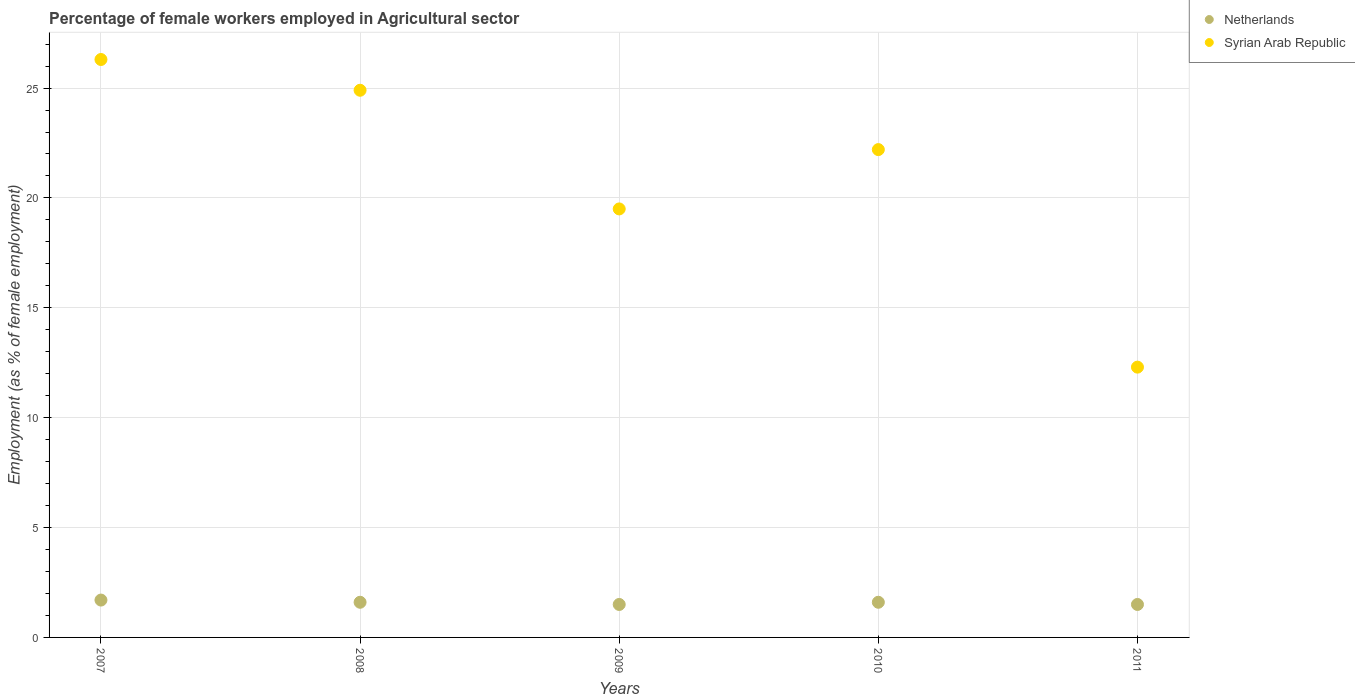How many different coloured dotlines are there?
Give a very brief answer. 2. What is the percentage of females employed in Agricultural sector in Netherlands in 2008?
Make the answer very short. 1.6. Across all years, what is the maximum percentage of females employed in Agricultural sector in Syrian Arab Republic?
Your response must be concise. 26.3. In which year was the percentage of females employed in Agricultural sector in Netherlands maximum?
Offer a very short reply. 2007. In which year was the percentage of females employed in Agricultural sector in Netherlands minimum?
Offer a very short reply. 2009. What is the total percentage of females employed in Agricultural sector in Netherlands in the graph?
Your response must be concise. 7.9. What is the difference between the percentage of females employed in Agricultural sector in Syrian Arab Republic in 2009 and that in 2010?
Your response must be concise. -2.7. What is the difference between the percentage of females employed in Agricultural sector in Syrian Arab Republic in 2007 and the percentage of females employed in Agricultural sector in Netherlands in 2010?
Your answer should be very brief. 24.7. What is the average percentage of females employed in Agricultural sector in Syrian Arab Republic per year?
Your response must be concise. 21.04. In the year 2007, what is the difference between the percentage of females employed in Agricultural sector in Syrian Arab Republic and percentage of females employed in Agricultural sector in Netherlands?
Provide a succinct answer. 24.6. In how many years, is the percentage of females employed in Agricultural sector in Netherlands greater than 10 %?
Ensure brevity in your answer.  0. What is the ratio of the percentage of females employed in Agricultural sector in Netherlands in 2010 to that in 2011?
Offer a very short reply. 1.07. Is the difference between the percentage of females employed in Agricultural sector in Syrian Arab Republic in 2008 and 2009 greater than the difference between the percentage of females employed in Agricultural sector in Netherlands in 2008 and 2009?
Give a very brief answer. Yes. What is the difference between the highest and the second highest percentage of females employed in Agricultural sector in Netherlands?
Ensure brevity in your answer.  0.1. What is the difference between the highest and the lowest percentage of females employed in Agricultural sector in Syrian Arab Republic?
Your answer should be very brief. 14. Is the sum of the percentage of females employed in Agricultural sector in Netherlands in 2008 and 2009 greater than the maximum percentage of females employed in Agricultural sector in Syrian Arab Republic across all years?
Give a very brief answer. No. How many dotlines are there?
Make the answer very short. 2. What is the difference between two consecutive major ticks on the Y-axis?
Offer a terse response. 5. Are the values on the major ticks of Y-axis written in scientific E-notation?
Give a very brief answer. No. Does the graph contain grids?
Give a very brief answer. Yes. How many legend labels are there?
Your response must be concise. 2. How are the legend labels stacked?
Ensure brevity in your answer.  Vertical. What is the title of the graph?
Provide a succinct answer. Percentage of female workers employed in Agricultural sector. What is the label or title of the Y-axis?
Offer a terse response. Employment (as % of female employment). What is the Employment (as % of female employment) of Netherlands in 2007?
Your answer should be very brief. 1.7. What is the Employment (as % of female employment) of Syrian Arab Republic in 2007?
Keep it short and to the point. 26.3. What is the Employment (as % of female employment) of Netherlands in 2008?
Your answer should be very brief. 1.6. What is the Employment (as % of female employment) in Syrian Arab Republic in 2008?
Give a very brief answer. 24.9. What is the Employment (as % of female employment) of Netherlands in 2009?
Keep it short and to the point. 1.5. What is the Employment (as % of female employment) of Syrian Arab Republic in 2009?
Your answer should be very brief. 19.5. What is the Employment (as % of female employment) of Netherlands in 2010?
Provide a succinct answer. 1.6. What is the Employment (as % of female employment) of Syrian Arab Republic in 2010?
Ensure brevity in your answer.  22.2. What is the Employment (as % of female employment) in Netherlands in 2011?
Your response must be concise. 1.5. What is the Employment (as % of female employment) of Syrian Arab Republic in 2011?
Make the answer very short. 12.3. Across all years, what is the maximum Employment (as % of female employment) in Netherlands?
Provide a succinct answer. 1.7. Across all years, what is the maximum Employment (as % of female employment) in Syrian Arab Republic?
Your response must be concise. 26.3. Across all years, what is the minimum Employment (as % of female employment) of Netherlands?
Offer a very short reply. 1.5. Across all years, what is the minimum Employment (as % of female employment) of Syrian Arab Republic?
Provide a short and direct response. 12.3. What is the total Employment (as % of female employment) in Netherlands in the graph?
Give a very brief answer. 7.9. What is the total Employment (as % of female employment) in Syrian Arab Republic in the graph?
Your answer should be very brief. 105.2. What is the difference between the Employment (as % of female employment) of Netherlands in 2007 and that in 2009?
Give a very brief answer. 0.2. What is the difference between the Employment (as % of female employment) of Netherlands in 2007 and that in 2010?
Your answer should be very brief. 0.1. What is the difference between the Employment (as % of female employment) of Netherlands in 2007 and that in 2011?
Your answer should be very brief. 0.2. What is the difference between the Employment (as % of female employment) in Netherlands in 2008 and that in 2009?
Offer a terse response. 0.1. What is the difference between the Employment (as % of female employment) of Netherlands in 2008 and that in 2011?
Make the answer very short. 0.1. What is the difference between the Employment (as % of female employment) of Syrian Arab Republic in 2008 and that in 2011?
Keep it short and to the point. 12.6. What is the difference between the Employment (as % of female employment) in Netherlands in 2010 and that in 2011?
Your response must be concise. 0.1. What is the difference between the Employment (as % of female employment) of Netherlands in 2007 and the Employment (as % of female employment) of Syrian Arab Republic in 2008?
Give a very brief answer. -23.2. What is the difference between the Employment (as % of female employment) of Netherlands in 2007 and the Employment (as % of female employment) of Syrian Arab Republic in 2009?
Offer a terse response. -17.8. What is the difference between the Employment (as % of female employment) of Netherlands in 2007 and the Employment (as % of female employment) of Syrian Arab Republic in 2010?
Your answer should be compact. -20.5. What is the difference between the Employment (as % of female employment) of Netherlands in 2007 and the Employment (as % of female employment) of Syrian Arab Republic in 2011?
Provide a succinct answer. -10.6. What is the difference between the Employment (as % of female employment) of Netherlands in 2008 and the Employment (as % of female employment) of Syrian Arab Republic in 2009?
Offer a very short reply. -17.9. What is the difference between the Employment (as % of female employment) of Netherlands in 2008 and the Employment (as % of female employment) of Syrian Arab Republic in 2010?
Your answer should be compact. -20.6. What is the difference between the Employment (as % of female employment) in Netherlands in 2009 and the Employment (as % of female employment) in Syrian Arab Republic in 2010?
Your response must be concise. -20.7. What is the difference between the Employment (as % of female employment) of Netherlands in 2009 and the Employment (as % of female employment) of Syrian Arab Republic in 2011?
Ensure brevity in your answer.  -10.8. What is the average Employment (as % of female employment) in Netherlands per year?
Your response must be concise. 1.58. What is the average Employment (as % of female employment) of Syrian Arab Republic per year?
Keep it short and to the point. 21.04. In the year 2007, what is the difference between the Employment (as % of female employment) of Netherlands and Employment (as % of female employment) of Syrian Arab Republic?
Keep it short and to the point. -24.6. In the year 2008, what is the difference between the Employment (as % of female employment) in Netherlands and Employment (as % of female employment) in Syrian Arab Republic?
Your answer should be very brief. -23.3. In the year 2010, what is the difference between the Employment (as % of female employment) of Netherlands and Employment (as % of female employment) of Syrian Arab Republic?
Your answer should be very brief. -20.6. In the year 2011, what is the difference between the Employment (as % of female employment) of Netherlands and Employment (as % of female employment) of Syrian Arab Republic?
Your answer should be compact. -10.8. What is the ratio of the Employment (as % of female employment) of Syrian Arab Republic in 2007 to that in 2008?
Your response must be concise. 1.06. What is the ratio of the Employment (as % of female employment) in Netherlands in 2007 to that in 2009?
Your answer should be very brief. 1.13. What is the ratio of the Employment (as % of female employment) of Syrian Arab Republic in 2007 to that in 2009?
Provide a succinct answer. 1.35. What is the ratio of the Employment (as % of female employment) in Netherlands in 2007 to that in 2010?
Offer a terse response. 1.06. What is the ratio of the Employment (as % of female employment) of Syrian Arab Republic in 2007 to that in 2010?
Offer a terse response. 1.18. What is the ratio of the Employment (as % of female employment) in Netherlands in 2007 to that in 2011?
Make the answer very short. 1.13. What is the ratio of the Employment (as % of female employment) of Syrian Arab Republic in 2007 to that in 2011?
Provide a short and direct response. 2.14. What is the ratio of the Employment (as % of female employment) in Netherlands in 2008 to that in 2009?
Your answer should be very brief. 1.07. What is the ratio of the Employment (as % of female employment) of Syrian Arab Republic in 2008 to that in 2009?
Keep it short and to the point. 1.28. What is the ratio of the Employment (as % of female employment) of Syrian Arab Republic in 2008 to that in 2010?
Provide a succinct answer. 1.12. What is the ratio of the Employment (as % of female employment) in Netherlands in 2008 to that in 2011?
Make the answer very short. 1.07. What is the ratio of the Employment (as % of female employment) of Syrian Arab Republic in 2008 to that in 2011?
Your response must be concise. 2.02. What is the ratio of the Employment (as % of female employment) in Syrian Arab Republic in 2009 to that in 2010?
Your response must be concise. 0.88. What is the ratio of the Employment (as % of female employment) of Syrian Arab Republic in 2009 to that in 2011?
Offer a very short reply. 1.59. What is the ratio of the Employment (as % of female employment) of Netherlands in 2010 to that in 2011?
Your answer should be very brief. 1.07. What is the ratio of the Employment (as % of female employment) of Syrian Arab Republic in 2010 to that in 2011?
Keep it short and to the point. 1.8. What is the difference between the highest and the second highest Employment (as % of female employment) of Netherlands?
Give a very brief answer. 0.1. What is the difference between the highest and the second highest Employment (as % of female employment) of Syrian Arab Republic?
Provide a succinct answer. 1.4. What is the difference between the highest and the lowest Employment (as % of female employment) in Netherlands?
Your answer should be very brief. 0.2. What is the difference between the highest and the lowest Employment (as % of female employment) of Syrian Arab Republic?
Your answer should be compact. 14. 